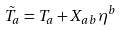<formula> <loc_0><loc_0><loc_500><loc_500>\tilde { T } _ { a } = T _ { a } + X _ { a b } \eta ^ { b }</formula> 